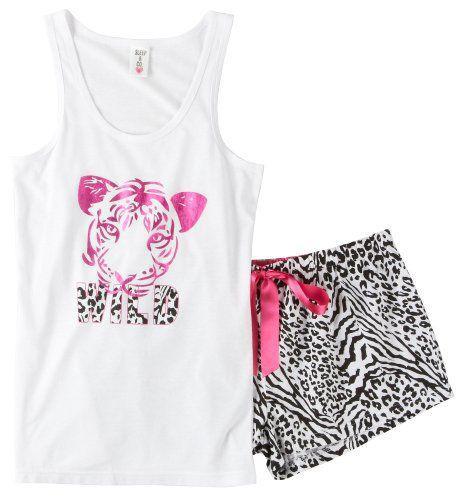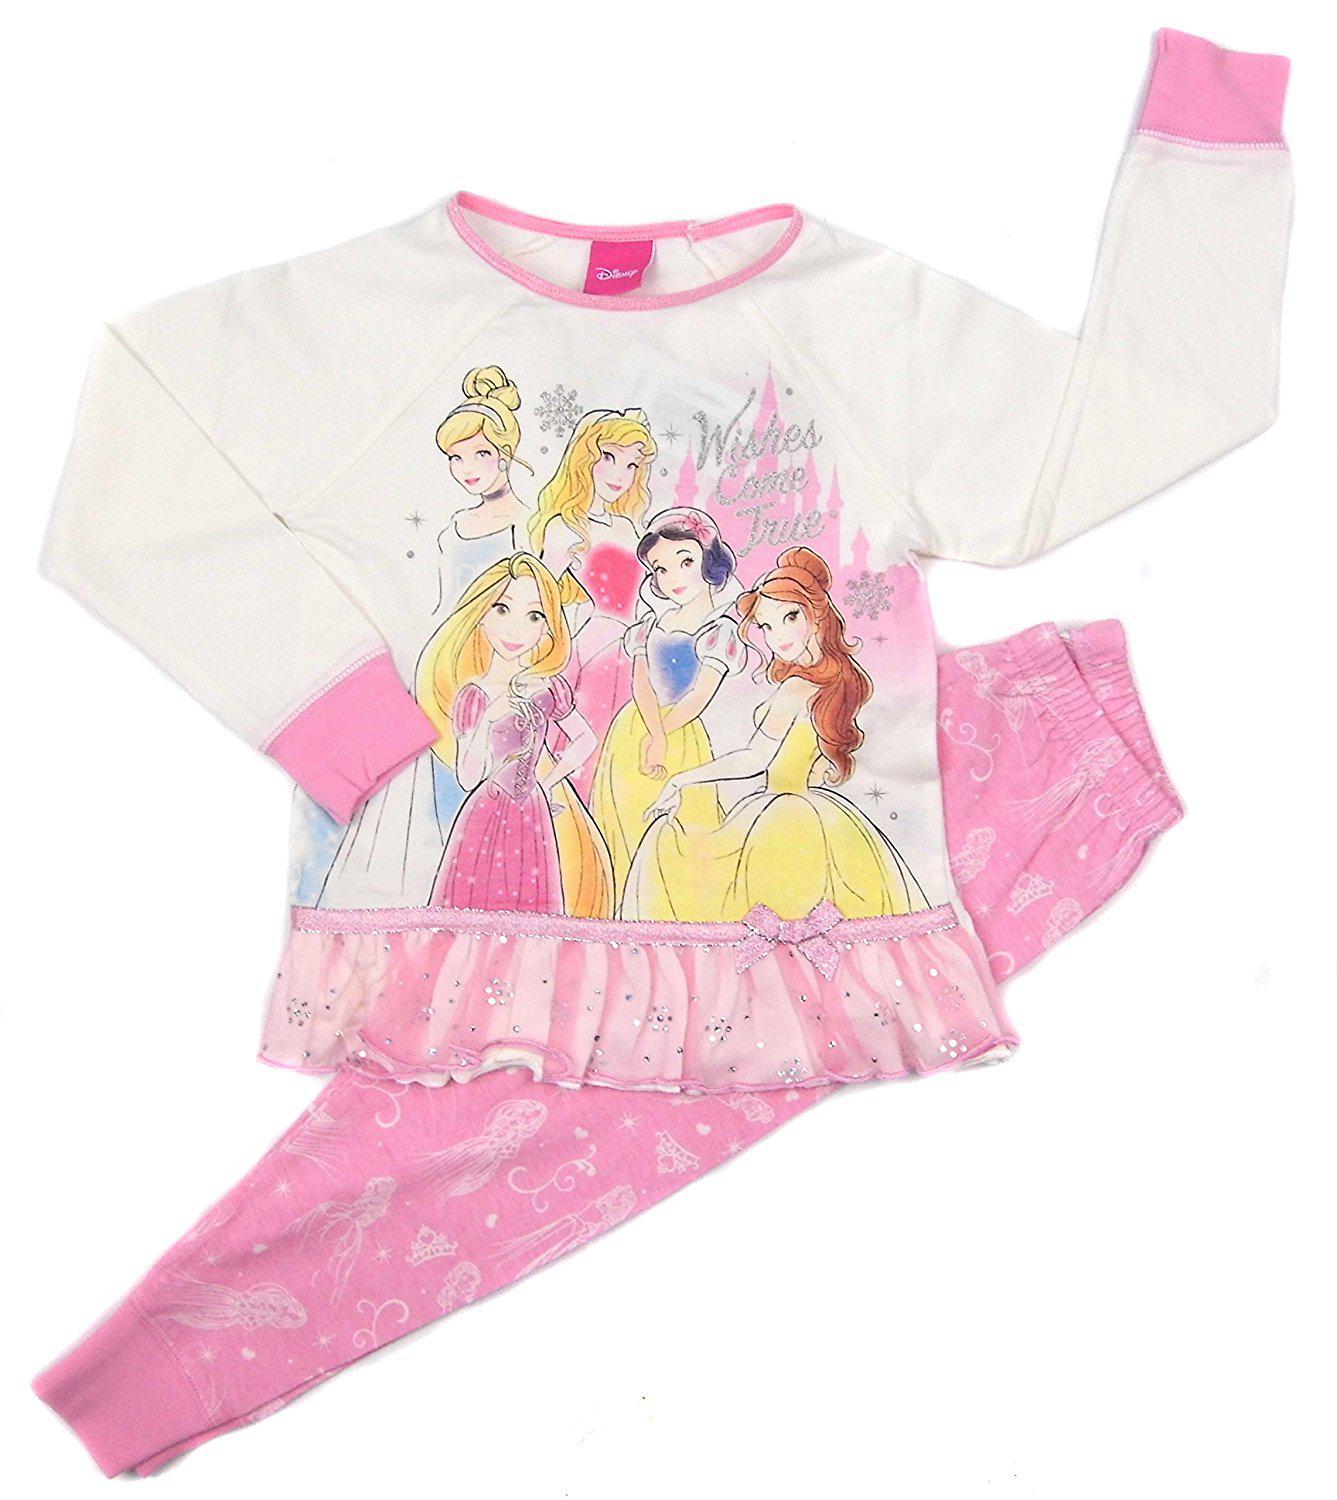The first image is the image on the left, the second image is the image on the right. For the images displayed, is the sentence "There are two outfits in one of the images." factually correct? Answer yes or no. No. The first image is the image on the left, the second image is the image on the right. Given the left and right images, does the statement "Sleepwear on the right features a Disney Princess theme on the front." hold true? Answer yes or no. Yes. 